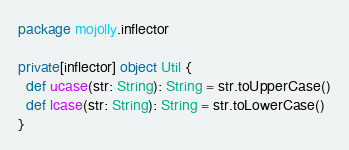<code> <loc_0><loc_0><loc_500><loc_500><_Scala_>package mojolly.inflector

private[inflector] object Util {
  def ucase(str: String): String = str.toUpperCase()
  def lcase(str: String): String = str.toLowerCase()
}</code> 